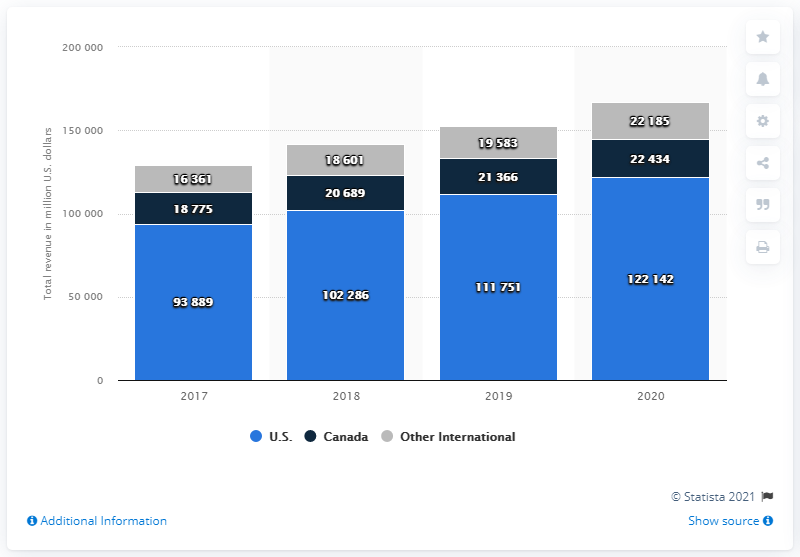Draw attention to some important aspects in this diagram. In the United States in 2020, Costco generated approximately $122,142,000 in revenue. 